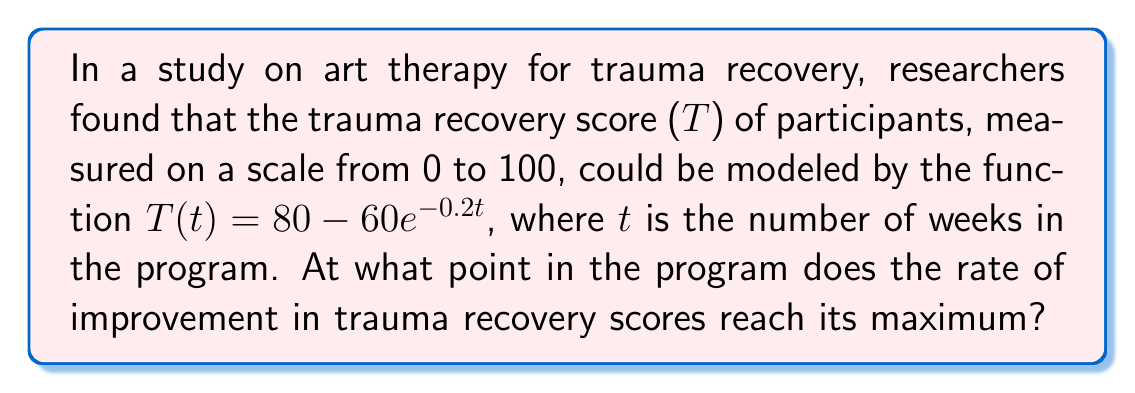Could you help me with this problem? To find the maximum rate of increase in trauma recovery scores, we need to follow these steps:

1) First, we need to find the rate of change of T with respect to t. This is given by the first derivative of T(t):

   $$\frac{dT}{dt} = 60 \cdot 0.2e^{-0.2t} = 12e^{-0.2t}$$

2) To find the maximum rate of increase, we need to find where the second derivative equals zero. The second derivative is:

   $$\frac{d^2T}{dt^2} = 12 \cdot (-0.2)e^{-0.2t} = -2.4e^{-0.2t}$$

3) Setting this equal to zero:

   $$-2.4e^{-0.2t} = 0$$

4) We can see that this equation is never exactly zero for any finite value of t. This means that the rate of increase is highest at the beginning of the program and decreases over time.

5) Therefore, the maximum rate of increase occurs when t = 0.

6) We can verify this by plugging t = 0 into the first derivative:

   $$\frac{dT}{dt}|_{t=0} = 12e^{-0.2(0)} = 12$$

So the maximum rate of increase is 12 points per week, occurring at the start of the program.
Answer: At t = 0 weeks (start of the program) 